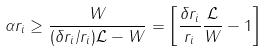Convert formula to latex. <formula><loc_0><loc_0><loc_500><loc_500>\alpha r _ { i } \geq \frac { W } { ( \delta r _ { i } / r _ { i } ) \mathcal { L } - W } = \left [ \frac { \delta r _ { i } } { r _ { i } } \frac { \mathcal { L } } { W } - 1 \right ]</formula> 